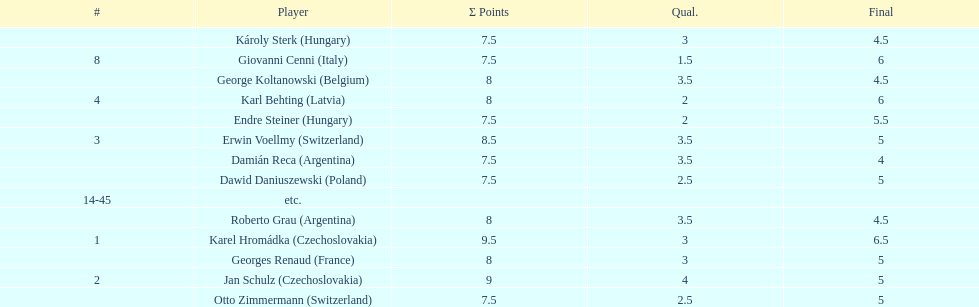Karl behting and giovanni cenni each had final scores of what? 6. 